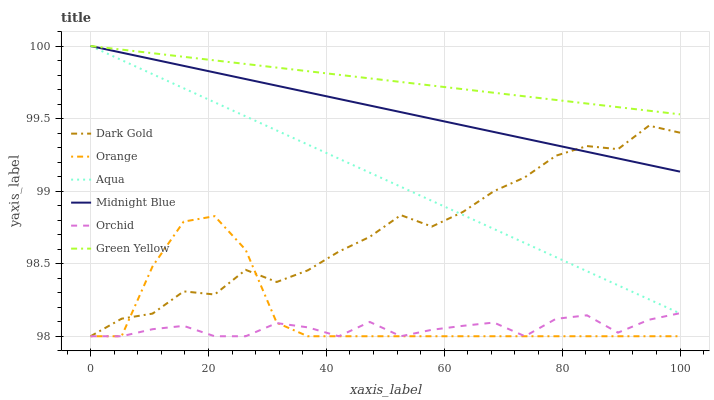Does Orchid have the minimum area under the curve?
Answer yes or no. Yes. Does Green Yellow have the maximum area under the curve?
Answer yes or no. Yes. Does Dark Gold have the minimum area under the curve?
Answer yes or no. No. Does Dark Gold have the maximum area under the curve?
Answer yes or no. No. Is Green Yellow the smoothest?
Answer yes or no. Yes. Is Dark Gold the roughest?
Answer yes or no. Yes. Is Aqua the smoothest?
Answer yes or no. No. Is Aqua the roughest?
Answer yes or no. No. Does Aqua have the lowest value?
Answer yes or no. No. Does Dark Gold have the highest value?
Answer yes or no. No. Is Orange less than Midnight Blue?
Answer yes or no. Yes. Is Midnight Blue greater than Orange?
Answer yes or no. Yes. Does Orange intersect Midnight Blue?
Answer yes or no. No. 